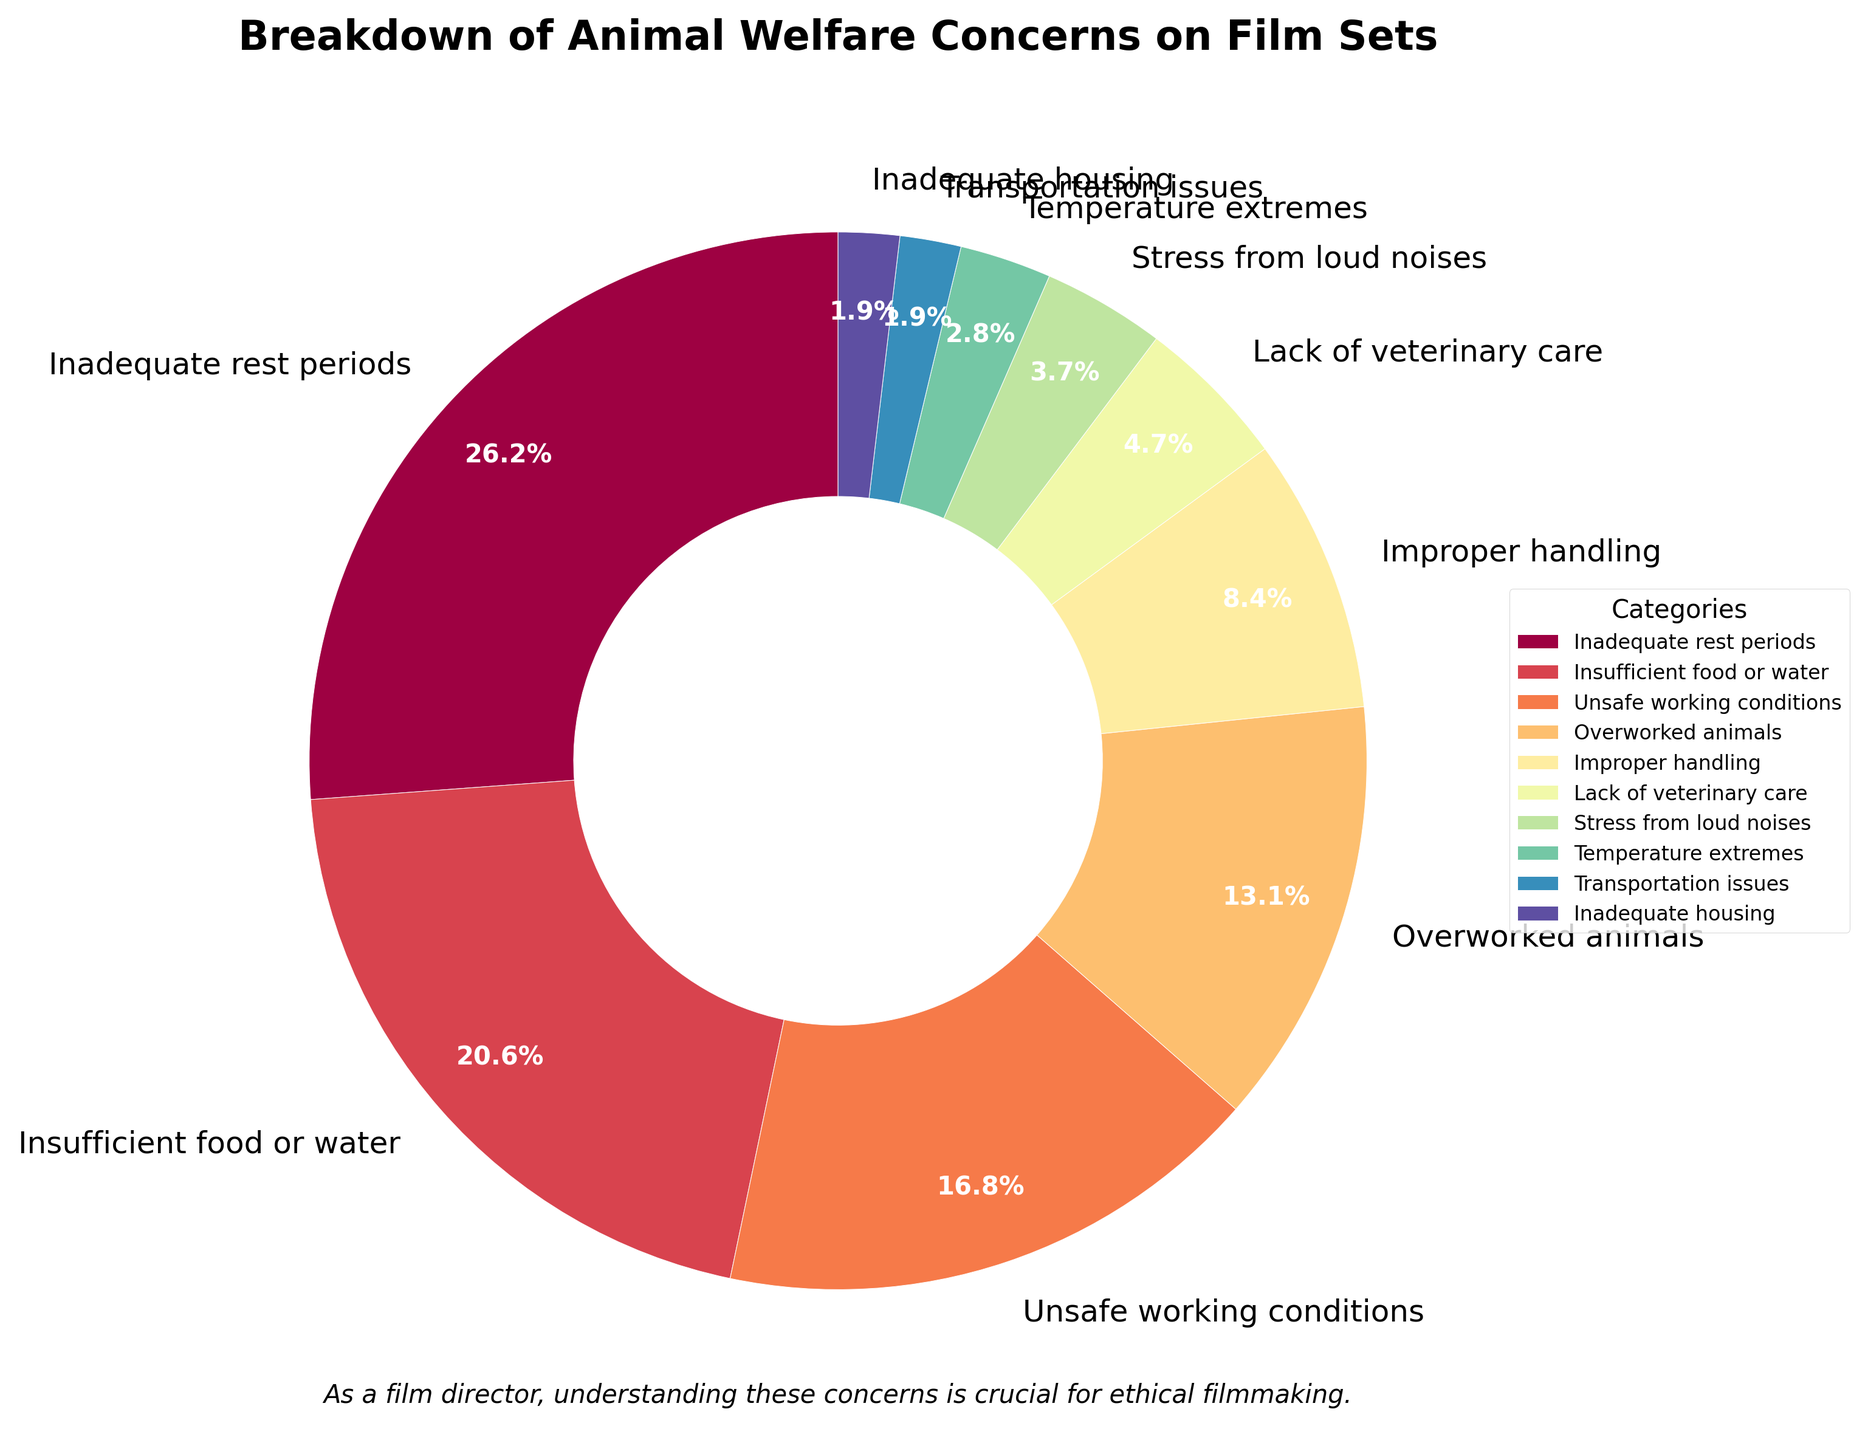What is the largest animal welfare concern reported on film sets? By looking at the pie chart, we can see that "Inadequate rest periods" occupies the largest section of the pie, which represents 28% of the concerns reported.
Answer: Inadequate rest periods How much more common is "Inadequate rest periods" compared to "Improper handling"? "Inadequate rest periods" is reported at 28%, while "Improper handling" is reported at 9%. Subtracting the latter from the former, we get 28% - 9% = 19%.
Answer: 19% If combined, what percentage do "Insufficient food or water" and "Unsafe working conditions" form? "Insufficient food or water" is 22%, and "Unsafe working conditions" is 18%. Adding them together, we get 22% + 18% = 40%.
Answer: 40% Which category has the smallest percentage, and what is its value? The pie chart shows that "Transportation issues" and "Inadequate housing" both have the smallest percentage, each at 2%.
Answer: Transportation issues and Inadequate housing, 2% Are there more reports of "Overworked animals" or "Improper handling"? The percentage for "Overworked animals" is 14%, whereas "Improper handling" is 9%. Therefore, "Overworked animals" has more reports.
Answer: Overworked animals What percentage of the concerns can be attributed to categories involving direct physical issues (Inadequate rest periods, Insufficient food or water, Unsafe working conditions, Overworked animals, Improper handling)? Add the percentages for the relevant categories: 28% + 22% + 18% + 14% + 9% = 91%.
Answer: 91% Which color represents the "Stress from loud noises" category in the pie chart? According to the color palette used, "Stress from loud noises" is a small segment and would be represented by the sixth color in the Spectral range, which might be a shade associated with that position.
Answer: Sixth color How does the percentage for "Stress from loud noises" compare to "Temperature extremes"? "Stress from loud noises" is reported at 4%, whereas "Temperature extremes" is at 3%. Thus, "Stress from loud noises" is 1% higher.
Answer: Stress from loud noises is 1% higher What is the combined percentage of the categories with 5% or less share each? Sum the percentages for "Lack of veterinary care" (5%), "Stress from loud noises" (4%), "Temperature extremes" (3%), "Transportation issues" (2%), and "Inadequate housing" (2%): 5% + 4% + 3% + 2% + 2% = 16%.
Answer: 16% If "Inadequate rest periods" and "Overworked animals" were addressed, what percentage of concerns would be resolved? "Inadequate rest periods" accounts for 28% and "Overworked animals" accounts for 14%. Adding these two percentages, we get 28% + 14% = 42%.
Answer: 42% 